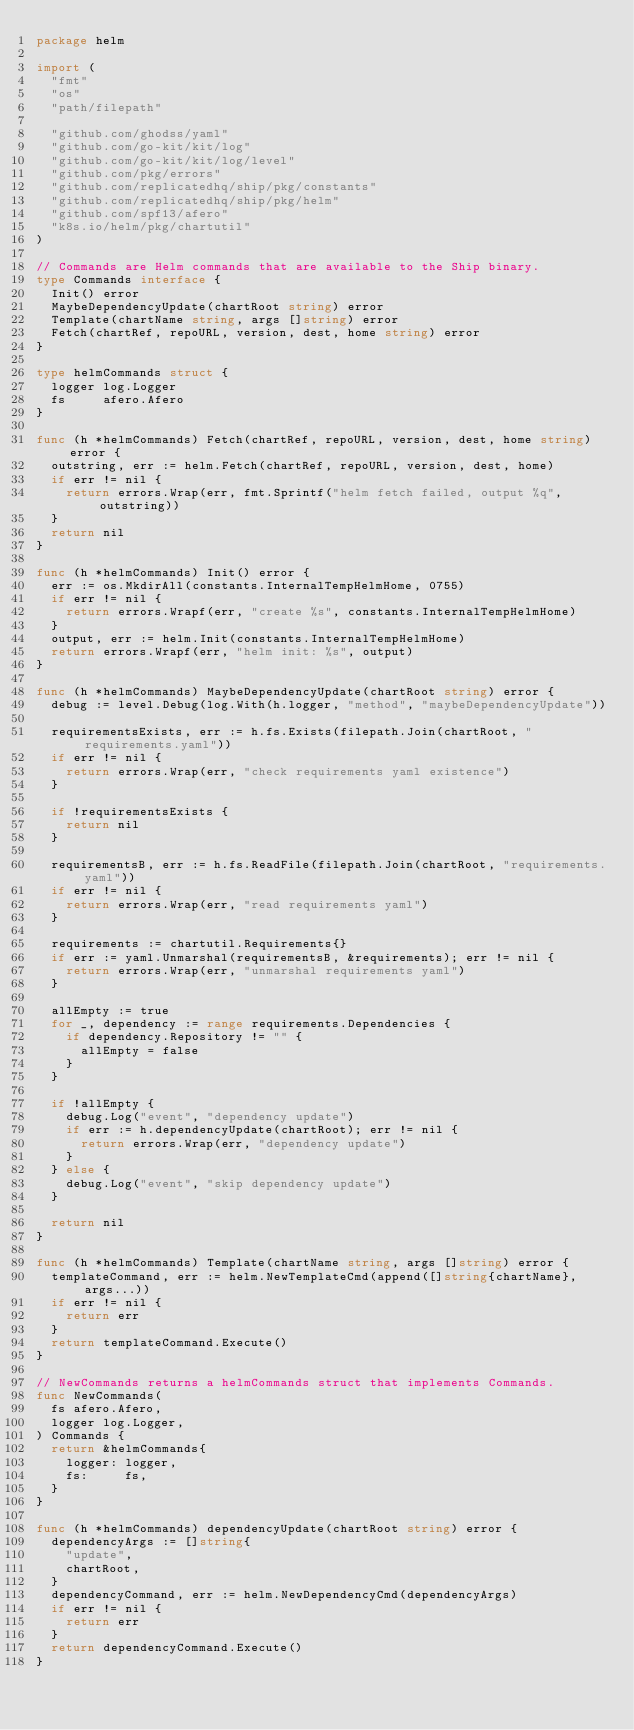Convert code to text. <code><loc_0><loc_0><loc_500><loc_500><_Go_>package helm

import (
	"fmt"
	"os"
	"path/filepath"

	"github.com/ghodss/yaml"
	"github.com/go-kit/kit/log"
	"github.com/go-kit/kit/log/level"
	"github.com/pkg/errors"
	"github.com/replicatedhq/ship/pkg/constants"
	"github.com/replicatedhq/ship/pkg/helm"
	"github.com/spf13/afero"
	"k8s.io/helm/pkg/chartutil"
)

// Commands are Helm commands that are available to the Ship binary.
type Commands interface {
	Init() error
	MaybeDependencyUpdate(chartRoot string) error
	Template(chartName string, args []string) error
	Fetch(chartRef, repoURL, version, dest, home string) error
}

type helmCommands struct {
	logger log.Logger
	fs     afero.Afero
}

func (h *helmCommands) Fetch(chartRef, repoURL, version, dest, home string) error {
	outstring, err := helm.Fetch(chartRef, repoURL, version, dest, home)
	if err != nil {
		return errors.Wrap(err, fmt.Sprintf("helm fetch failed, output %q", outstring))
	}
	return nil
}

func (h *helmCommands) Init() error {
	err := os.MkdirAll(constants.InternalTempHelmHome, 0755)
	if err != nil {
		return errors.Wrapf(err, "create %s", constants.InternalTempHelmHome)
	}
	output, err := helm.Init(constants.InternalTempHelmHome)
	return errors.Wrapf(err, "helm init: %s", output)
}

func (h *helmCommands) MaybeDependencyUpdate(chartRoot string) error {
	debug := level.Debug(log.With(h.logger, "method", "maybeDependencyUpdate"))

	requirementsExists, err := h.fs.Exists(filepath.Join(chartRoot, "requirements.yaml"))
	if err != nil {
		return errors.Wrap(err, "check requirements yaml existence")
	}

	if !requirementsExists {
		return nil
	}

	requirementsB, err := h.fs.ReadFile(filepath.Join(chartRoot, "requirements.yaml"))
	if err != nil {
		return errors.Wrap(err, "read requirements yaml")
	}

	requirements := chartutil.Requirements{}
	if err := yaml.Unmarshal(requirementsB, &requirements); err != nil {
		return errors.Wrap(err, "unmarshal requirements yaml")
	}

	allEmpty := true
	for _, dependency := range requirements.Dependencies {
		if dependency.Repository != "" {
			allEmpty = false
		}
	}

	if !allEmpty {
		debug.Log("event", "dependency update")
		if err := h.dependencyUpdate(chartRoot); err != nil {
			return errors.Wrap(err, "dependency update")
		}
	} else {
		debug.Log("event", "skip dependency update")
	}

	return nil
}

func (h *helmCommands) Template(chartName string, args []string) error {
	templateCommand, err := helm.NewTemplateCmd(append([]string{chartName}, args...))
	if err != nil {
		return err
	}
	return templateCommand.Execute()
}

// NewCommands returns a helmCommands struct that implements Commands.
func NewCommands(
	fs afero.Afero,
	logger log.Logger,
) Commands {
	return &helmCommands{
		logger: logger,
		fs:     fs,
	}
}

func (h *helmCommands) dependencyUpdate(chartRoot string) error {
	dependencyArgs := []string{
		"update",
		chartRoot,
	}
	dependencyCommand, err := helm.NewDependencyCmd(dependencyArgs)
	if err != nil {
		return err
	}
	return dependencyCommand.Execute()
}
</code> 